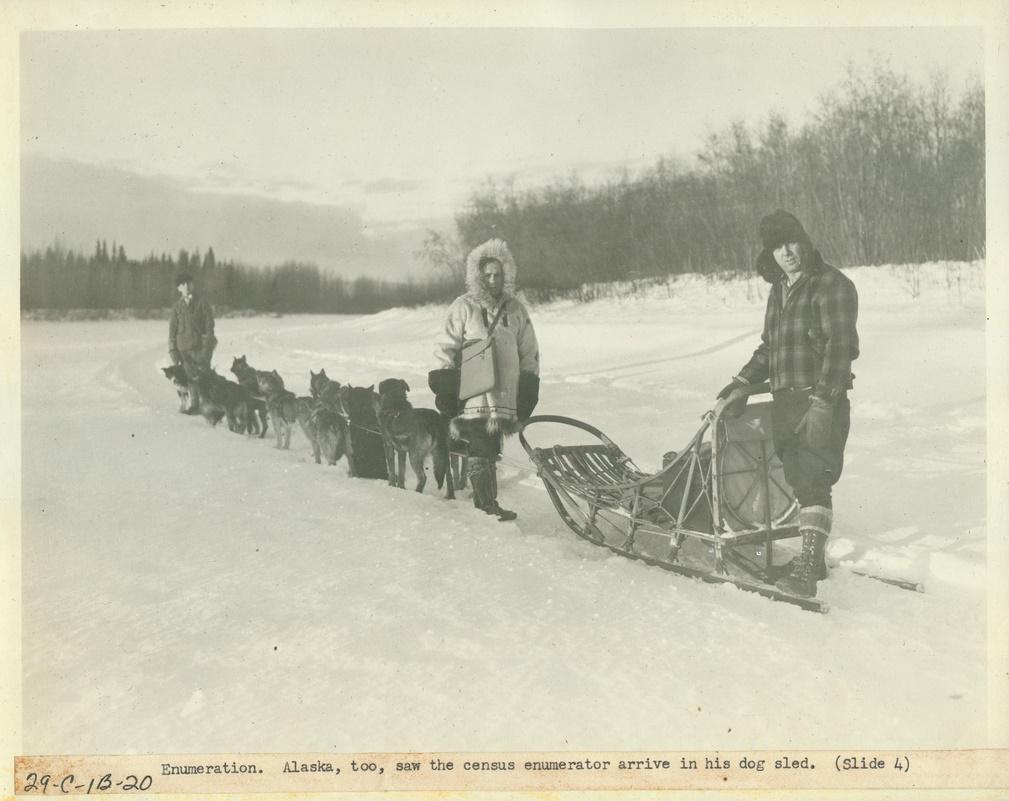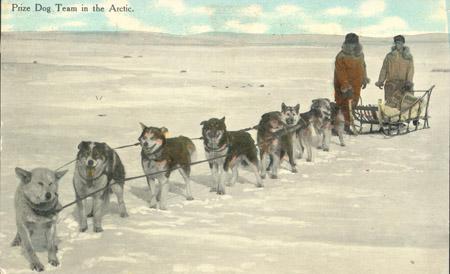The first image is the image on the left, the second image is the image on the right. For the images shown, is this caption "In the image to the right, the lead dog is a white husky." true? Answer yes or no. Yes. The first image is the image on the left, the second image is the image on the right. Analyze the images presented: Is the assertion "The left image contains only one sled, which is wooden and hitched to at least one leftward-turned dog with a person standing by the dog." valid? Answer yes or no. Yes. 